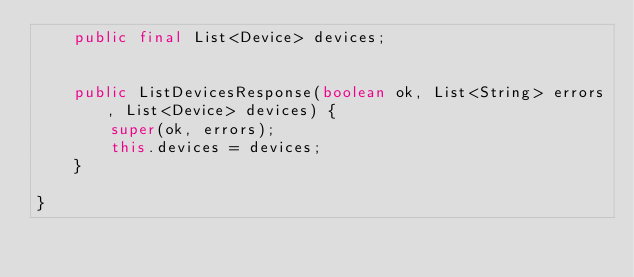Convert code to text. <code><loc_0><loc_0><loc_500><loc_500><_Java_>	public final List<Device> devices;


	public ListDevicesResponse(boolean ok, List<String> errors, List<Device> devices) {
		super(ok, errors);
		this.devices = devices;
	}

}
</code> 